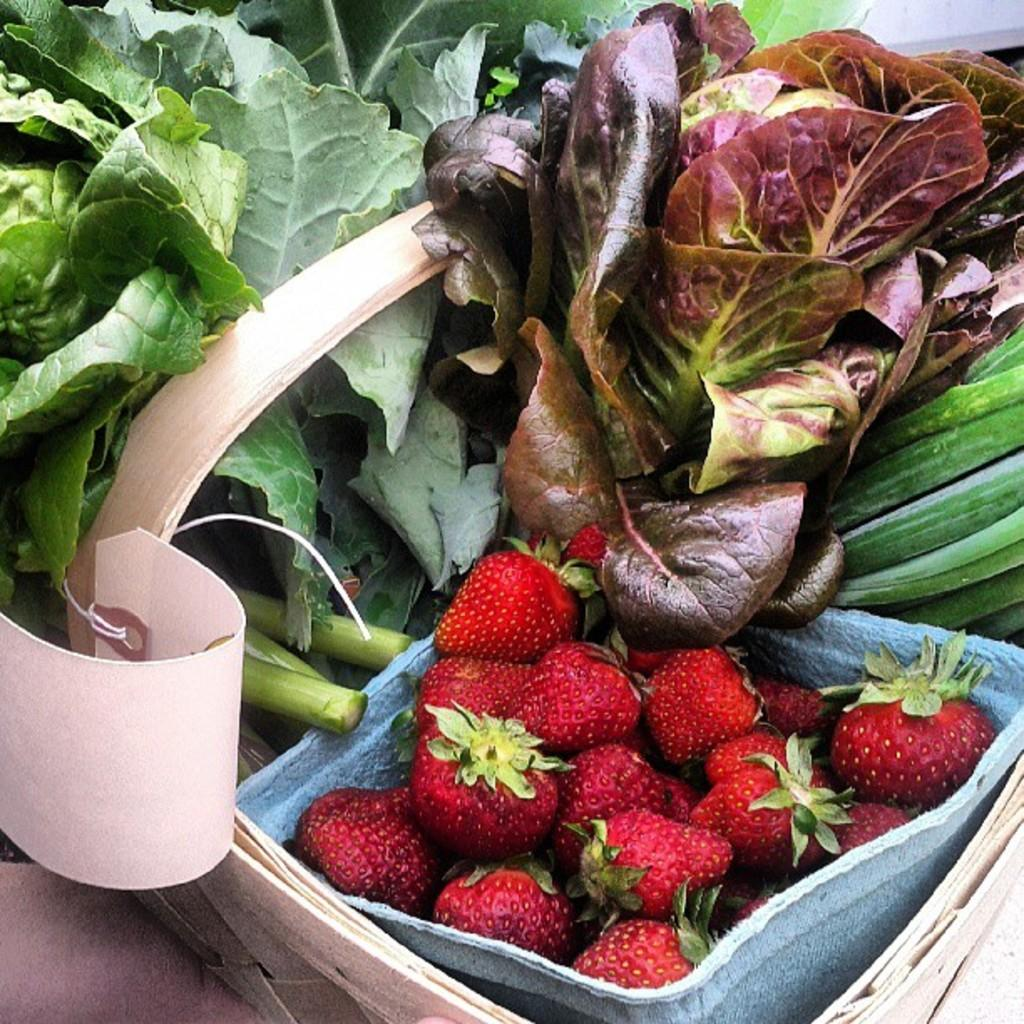What type of fruit is in the bowl in the image? There are strawberries in a bowl in the image. What type of vegetation is visible in the image? There are leaves visible in the image. What type of objects are in the image that might be used for playing or entertainment? There are cards in the image. Can you see the ocean in the image? No, the ocean is not present in the image. Is there a stamp visible on any of the cards in the image? There is no mention of a stamp on any of the cards in the image. 